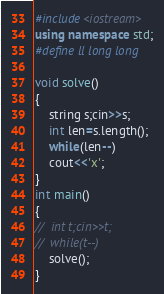Convert code to text. <code><loc_0><loc_0><loc_500><loc_500><_C++_>#include<iostream>
using namespace std;
#define ll long long

void solve()
{
	string s;cin>>s;
	int len=s.length();
	while(len--)
	cout<<'x';
}
int main()
{
//	int t;cin>>t;
//	while(t--)
	solve();
}
</code> 